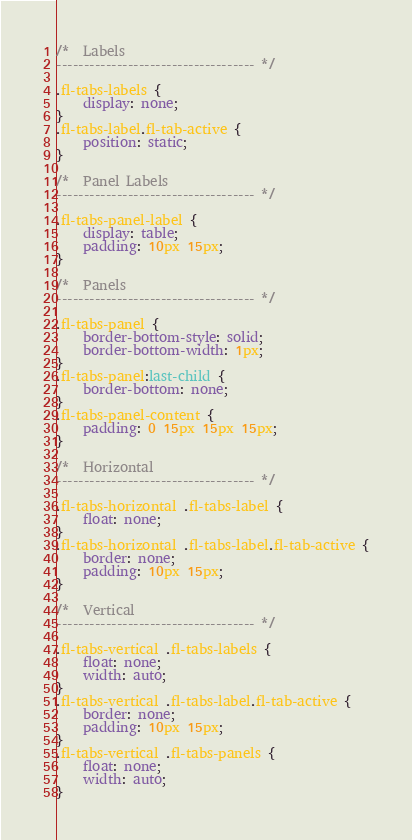<code> <loc_0><loc_0><loc_500><loc_500><_CSS_>/*  Labels
------------------------------------ */

.fl-tabs-labels {
	display: none;
}
.fl-tabs-label.fl-tab-active {
	position: static;
}

/*  Panel Labels
------------------------------------ */

.fl-tabs-panel-label {
	display: table;
	padding: 10px 15px;
}

/*  Panels
------------------------------------ */

.fl-tabs-panel {
	border-bottom-style: solid;
	border-bottom-width: 1px;
}
.fl-tabs-panel:last-child {
	border-bottom: none;
}
.fl-tabs-panel-content {
	padding: 0 15px 15px 15px;
}

/*  Horizontal
------------------------------------ */

.fl-tabs-horizontal .fl-tabs-label {
	float: none;
}
.fl-tabs-horizontal .fl-tabs-label.fl-tab-active {
	border: none;
	padding: 10px 15px;
}

/*  Vertical
------------------------------------ */

.fl-tabs-vertical .fl-tabs-labels {
	float: none;
	width: auto;
}
.fl-tabs-vertical .fl-tabs-label.fl-tab-active {
	border: none;
	padding: 10px 15px;
}
.fl-tabs-vertical .fl-tabs-panels {
	float: none;
	width: auto;
}</code> 